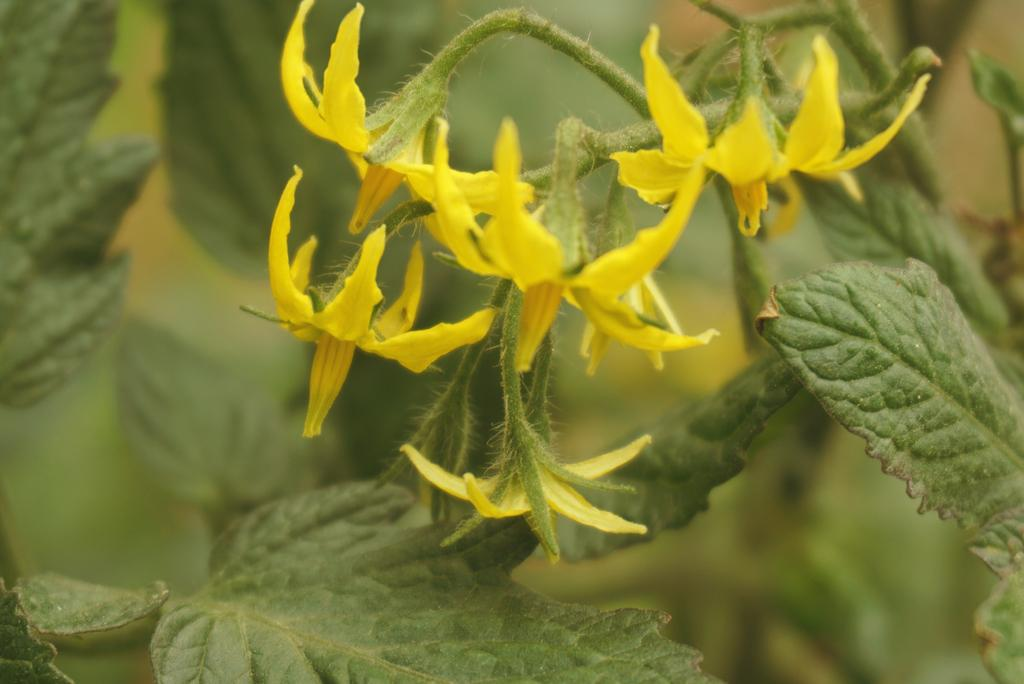What type of flowers are on the plant in the image? There are yellow flowers on the plant in the image. What color are the leaves on the plant? The leaves on the plant are green. Can you describe the background of the image? The background of the image is blurred. What type of authority figure can be seen in the image? There is no authority figure present in the image; it features a plant with yellow flowers and green leaves against a blurred background. 